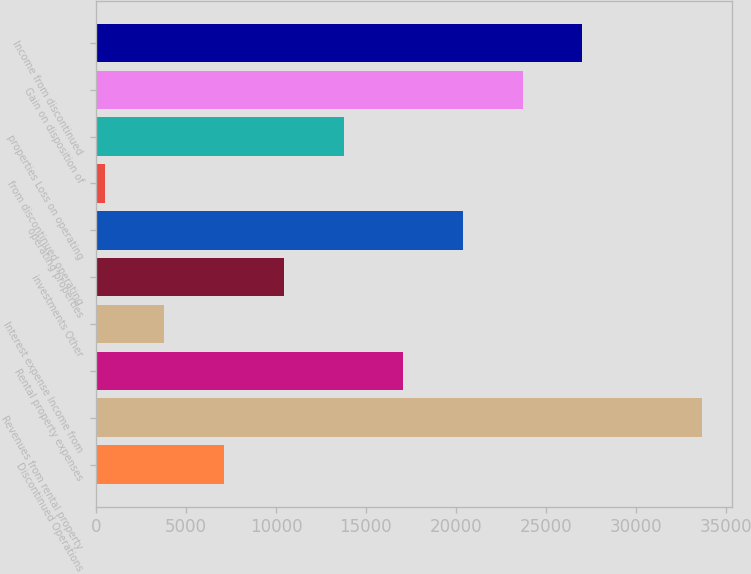Convert chart. <chart><loc_0><loc_0><loc_500><loc_500><bar_chart><fcel>Discontinued Operations<fcel>Revenues from rental property<fcel>Rental property expenses<fcel>Interest expense Income from<fcel>investments Other<fcel>operating properties<fcel>from discontinued operating<fcel>properties Loss on operating<fcel>Gain on disposition of<fcel>Income from discontinued<nl><fcel>7118.8<fcel>33670<fcel>17075.5<fcel>3799.9<fcel>10437.7<fcel>20394.4<fcel>481<fcel>13756.6<fcel>23713.3<fcel>27032.2<nl></chart> 